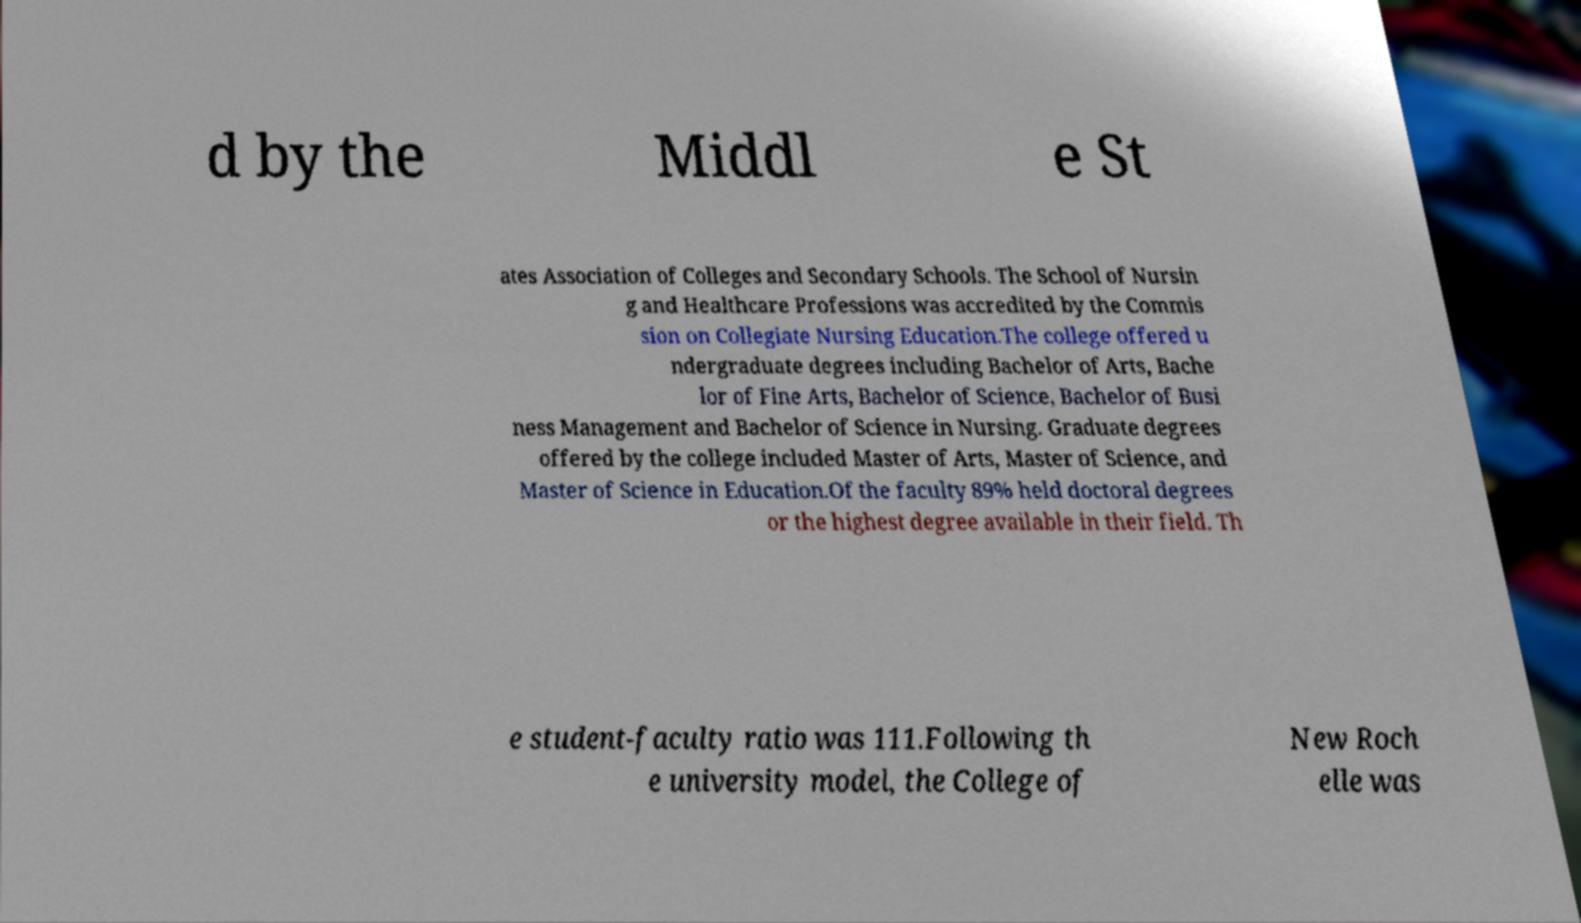Could you extract and type out the text from this image? d by the Middl e St ates Association of Colleges and Secondary Schools. The School of Nursin g and Healthcare Professions was accredited by the Commis sion on Collegiate Nursing Education.The college offered u ndergraduate degrees including Bachelor of Arts, Bache lor of Fine Arts, Bachelor of Science, Bachelor of Busi ness Management and Bachelor of Science in Nursing. Graduate degrees offered by the college included Master of Arts, Master of Science, and Master of Science in Education.Of the faculty 89% held doctoral degrees or the highest degree available in their field. Th e student-faculty ratio was 111.Following th e university model, the College of New Roch elle was 